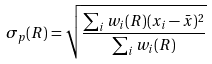<formula> <loc_0><loc_0><loc_500><loc_500>\sigma _ { p } ( R ) = \sqrt { \frac { \sum _ { i } w _ { i } ( R ) ( x _ { i } - \bar { x } ) ^ { 2 } } { { \sum _ { i } w _ { i } ( R ) } } }</formula> 